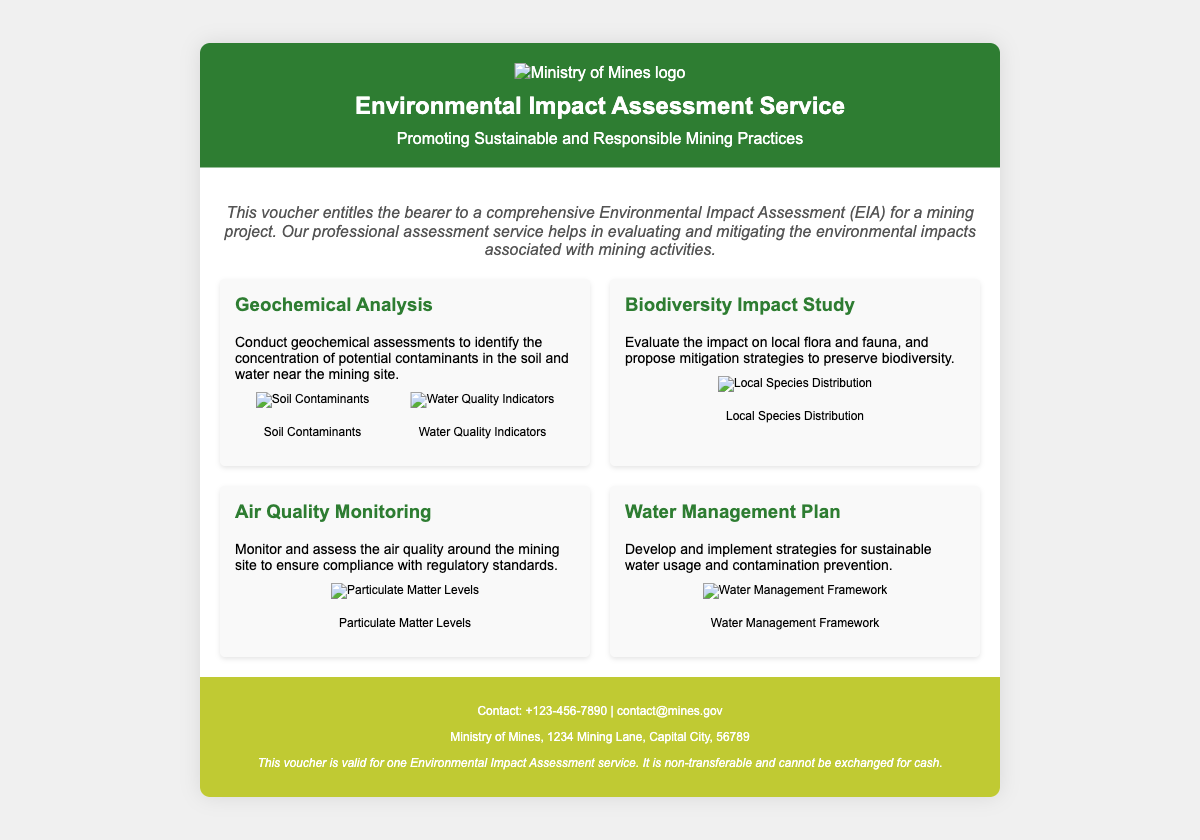What is the title of the voucher? The title can be found at the top of the document in the header section.
Answer: Environmental Impact Assessment Service What type of service does the voucher provide? This can be found in the introduction section of the document.
Answer: Environmental Impact Assessment Who is the contact for inquiries? Contact information is provided at the bottom of the document.
Answer: +123-456-7890 What is the main purpose of the EIA service? The purpose is outlined in the introduction section of the document.
Answer: Evaluating and mitigating environmental impacts How many types of services are described in the document? The number of services can be counted from the service grid in the body section.
Answer: Four What is the color of the header background? The color can be observed in the design description of the document.
Answer: Dark Green Is this voucher transferable? This information is found in the terms section at the bottom of the document.
Answer: No What type of analysis is offered as one of the services? This can be identified by looking at the service titles in the document.
Answer: Geochemical Analysis What is depicted in the water management framework diagram? The description of services provides insight into the content of the diagrams.
Answer: Water Management Framework 